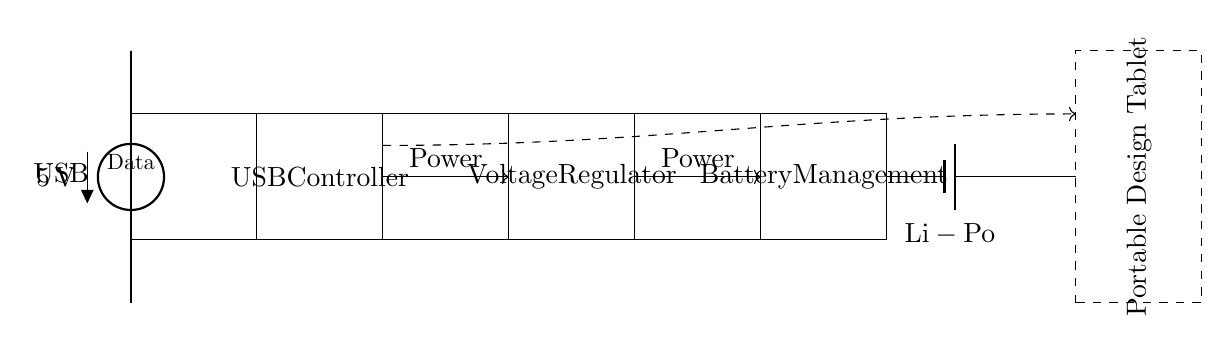What is the voltage source in the circuit? The source in the circuit is labeled as USB, and it provides a specified voltage of 5 volts directly from the diagram.
Answer: USB 5V What is the type of battery used in the circuit? The battery is labeled as a Li-Po battery, which stands for lithium polymer, and it is indicated in the circuit diagram.
Answer: Li-Po How many main components are shown in the circuit? The circuit diagram shows four main components: the USB controller, voltage regulator, battery management, and the battery itself.
Answer: Four What is the purpose of the USB controller in this circuit? The USB controller manages the power and data transfer between the USB source and other components, ensuring proper charging of the battery and data communication to the tablet.
Answer: Power and data management What type of output does the circuit provide to the portable design tablet? The diagram indicates that the circuit provides both power and data to the portable design tablet, showing that it actively supports functionality beyond just charging.
Answer: Power and data How does the power flow from the USB source to the design tablet? Power flows from the USB source to the USB controller, then to the voltage regulator, followed by the battery management system, and finally to the portable design tablet. This path is represented with directional arrows indicating the flow of power through the circuit.
Answer: Through USB controller to voltage regulator to battery management to tablet Why is a voltage regulator used in this circuit? The voltage regulator is used to ensure that the output voltage remains stable and within a specified range suitable for charging the battery and powering the portable design tablet, which may require a different voltage level than the input USB voltage.
Answer: For voltage stability 